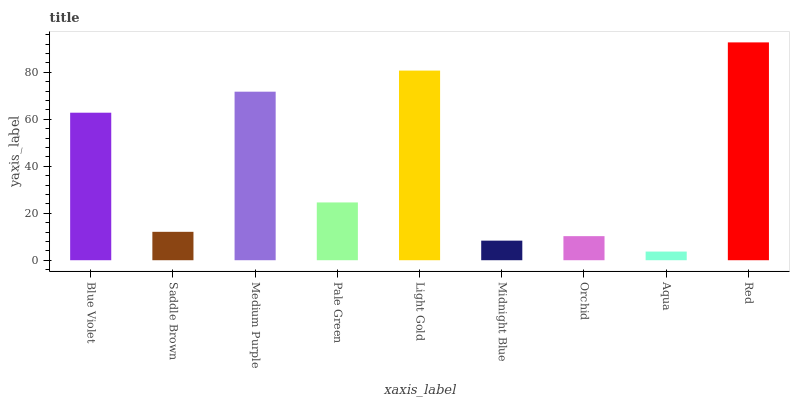Is Aqua the minimum?
Answer yes or no. Yes. Is Red the maximum?
Answer yes or no. Yes. Is Saddle Brown the minimum?
Answer yes or no. No. Is Saddle Brown the maximum?
Answer yes or no. No. Is Blue Violet greater than Saddle Brown?
Answer yes or no. Yes. Is Saddle Brown less than Blue Violet?
Answer yes or no. Yes. Is Saddle Brown greater than Blue Violet?
Answer yes or no. No. Is Blue Violet less than Saddle Brown?
Answer yes or no. No. Is Pale Green the high median?
Answer yes or no. Yes. Is Pale Green the low median?
Answer yes or no. Yes. Is Saddle Brown the high median?
Answer yes or no. No. Is Orchid the low median?
Answer yes or no. No. 